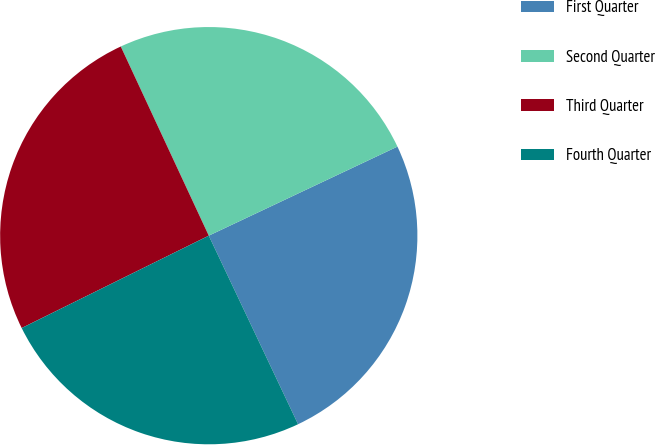<chart> <loc_0><loc_0><loc_500><loc_500><pie_chart><fcel>First Quarter<fcel>Second Quarter<fcel>Third Quarter<fcel>Fourth Quarter<nl><fcel>24.98%<fcel>24.91%<fcel>25.37%<fcel>24.74%<nl></chart> 